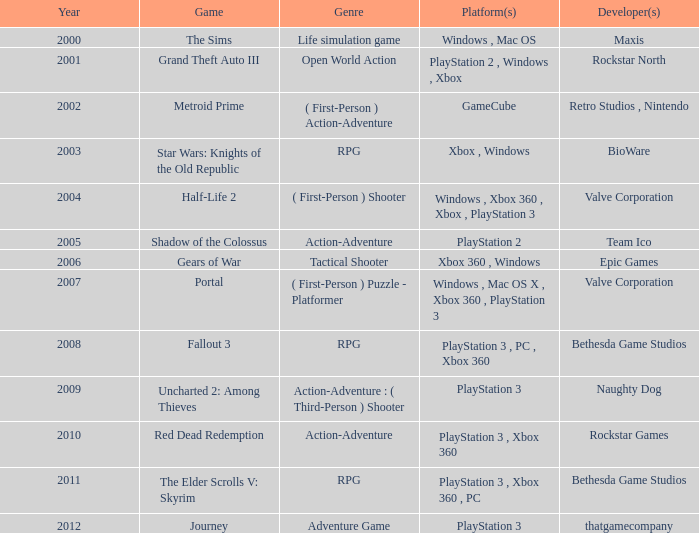What game was in 2005? Shadow of the Colossus. 